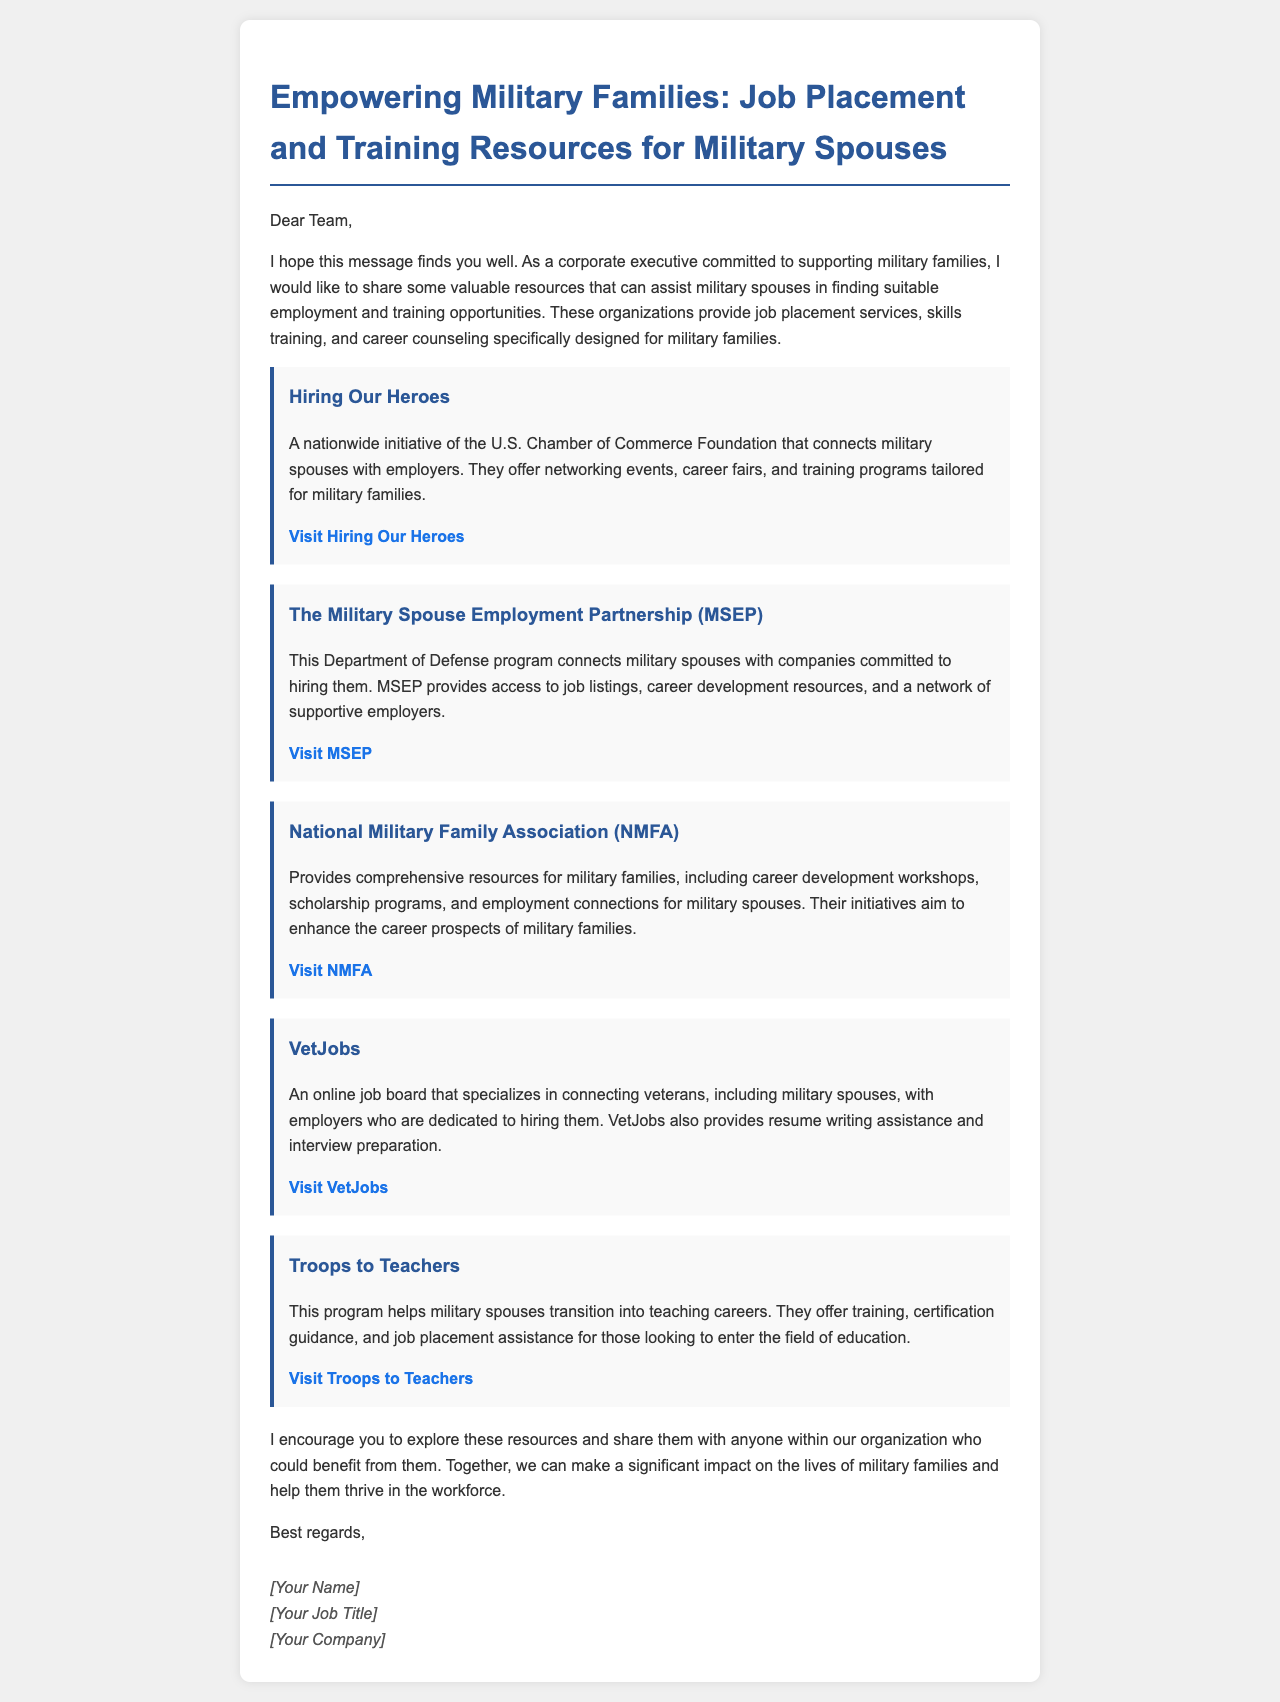What is the title of the document? The title of the document appears at the top of the email and summarizes its purpose in helping military families.
Answer: Empowering Military Families: Job Placement and Training Resources for Military Spouses What organization offers career fairs and training programs for military spouses? This information is provided under the "Hiring Our Heroes" section, which describes their initiatives specifically for military families.
Answer: Hiring Our Heroes What does MSEP stand for? The document mentions MSEP in connection with the Department of Defense program and provides its full name.
Answer: Military Spouse Employment Partnership How many resources are listed in the document? The document presents a total of five resources meant to aid military spouses in their employment journey.
Answer: Five Which organization helps military spouses transition into teaching careers? The specific program that focuses on assisting military spouses with entering the education field is clearly stated in the document.
Answer: Troops to Teachers What type of assistance does VetJobs provide? The document mentions the type of help that VetJobs offers, which specifically includes hiring-related services.
Answer: Resume writing assistance What is the focus of the National Military Family Association? The document outlines the services that this association provides, particularly targeting military spouses and families in employment situations.
Answer: Comprehensive resources for military families What is the primary goal mentioned in the email regarding military families? The email makes it clear that the overarching aim is to support and uplift military families through employment opportunities.
Answer: Make a significant impact on the lives of military families 